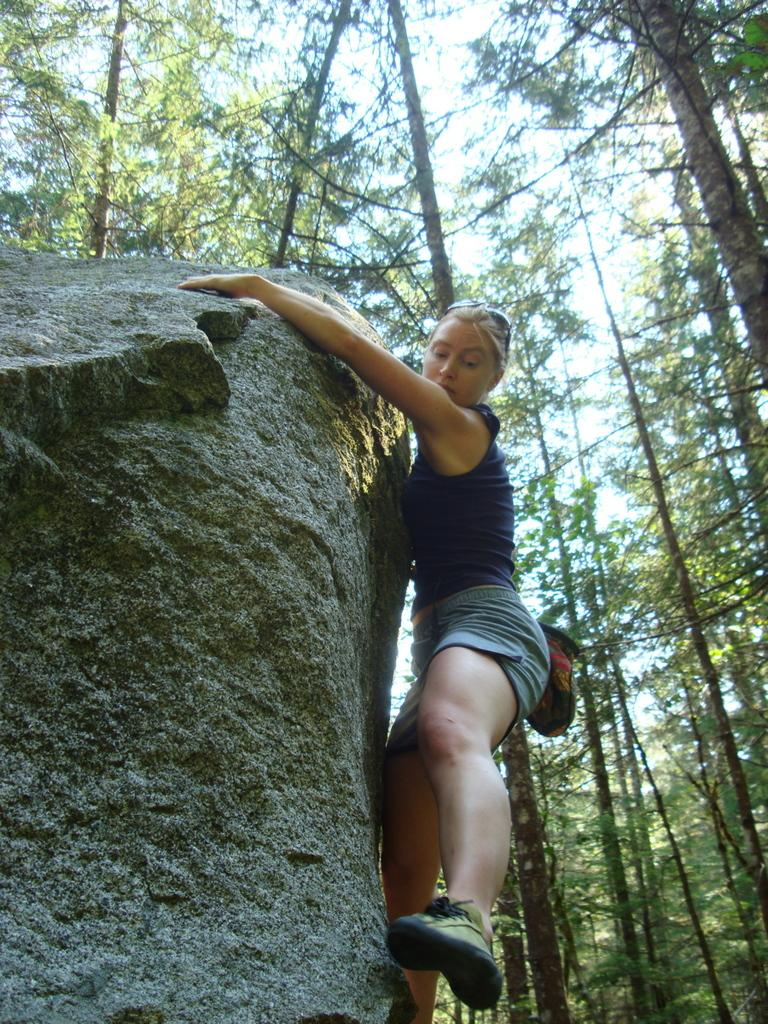Who is present in the image? There is a woman in the image. What is the woman holding in the image? The woman is holding a rock. What can be seen in the background of the image? There is a group of trees and the sky visible in the background of the image. What type of sack is the woman using to lift the rock in the image? There is no sack present in the image, and the woman is not lifting the rock. 